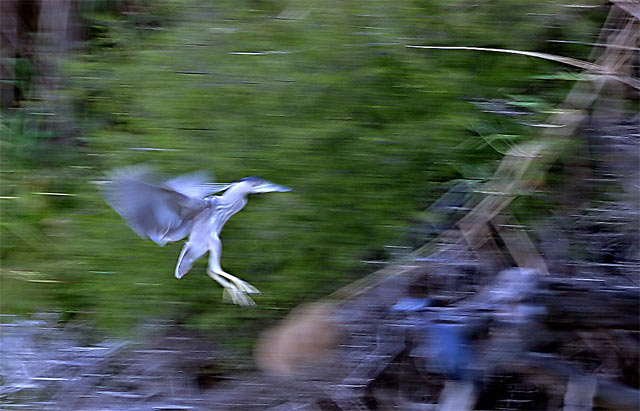What emotion does this image evoke? The image evokes a sense of swift movement and freedom, as the bird is captured in mid-flight, suggesting grace and the beauty of nature in motion. Additionally, the blur effect gives it an artistic quality that can instill a feeling of dynamism and energy. 